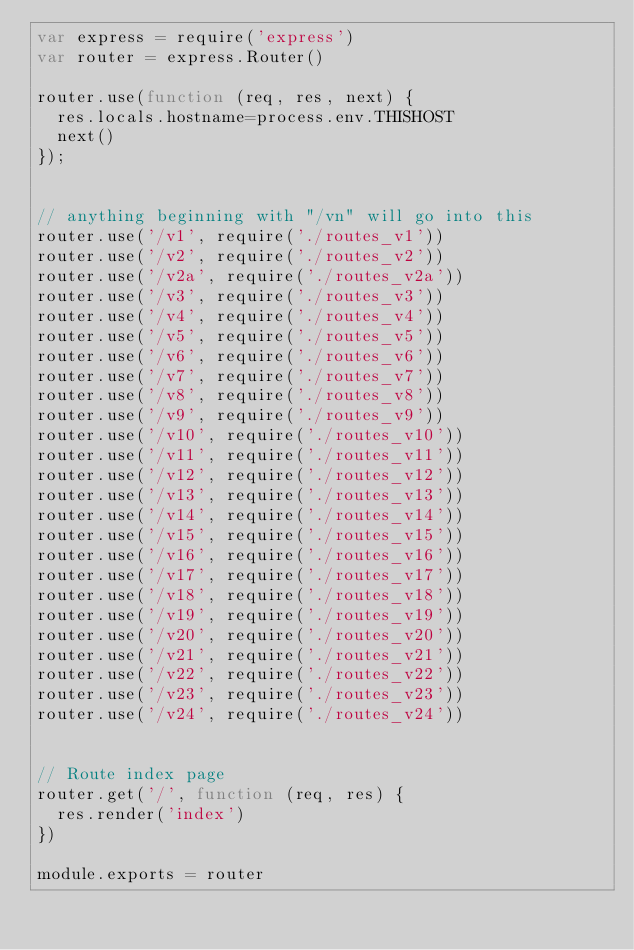<code> <loc_0><loc_0><loc_500><loc_500><_JavaScript_>var express = require('express')
var router = express.Router()

router.use(function (req, res, next) {
  res.locals.hostname=process.env.THISHOST
  next()
});


// anything beginning with "/vn" will go into this
router.use('/v1', require('./routes_v1'))
router.use('/v2', require('./routes_v2'))
router.use('/v2a', require('./routes_v2a'))
router.use('/v3', require('./routes_v3'))
router.use('/v4', require('./routes_v4'))
router.use('/v5', require('./routes_v5'))
router.use('/v6', require('./routes_v6'))
router.use('/v7', require('./routes_v7'))
router.use('/v8', require('./routes_v8'))
router.use('/v9', require('./routes_v9'))
router.use('/v10', require('./routes_v10'))
router.use('/v11', require('./routes_v11'))
router.use('/v12', require('./routes_v12'))
router.use('/v13', require('./routes_v13'))
router.use('/v14', require('./routes_v14'))
router.use('/v15', require('./routes_v15'))
router.use('/v16', require('./routes_v16'))
router.use('/v17', require('./routes_v17'))
router.use('/v18', require('./routes_v18'))
router.use('/v19', require('./routes_v19'))
router.use('/v20', require('./routes_v20'))
router.use('/v21', require('./routes_v21'))
router.use('/v22', require('./routes_v22'))
router.use('/v23', require('./routes_v23'))
router.use('/v24', require('./routes_v24'))


// Route index page
router.get('/', function (req, res) {
  res.render('index')
})

module.exports = router
</code> 